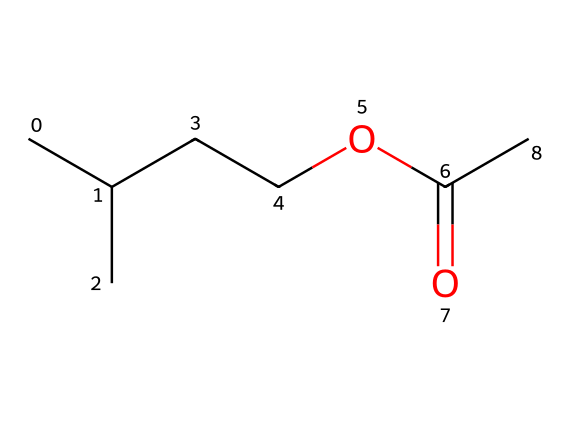What is the name of this chemical? The SMILES representation indicates a molecule made up of five carbon atoms, two from the branched chain and three from the structure connected to the ester functional group. This particular structure corresponds to isopentyl acetate, commonly known for its banana scent.
Answer: isopentyl acetate How many carbon atoms are in isopentyl acetate? By examining the SMILES structure, we see there are five 'C's present, which correspond to the carbon atoms in the molecule. The count includes both the branched and ester sections.
Answer: five What functional group does isopentyl acetate contain? The ester functional group is represented by the segment "OC(=O)", where the carbonyl (C=O) is attached to an oxygen that links to the hydrocarbon part. This identifies it as an ester.
Answer: ester What is the molecular formula for isopentyl acetate? From the SMILES representation, we can derive the number of atoms: 5 carbon, 10 hydrogen, and 2 oxygen atoms, leading to the molecular formula C5H10O2.
Answer: C5H10O2 Why does isopentyl acetate smell like bananas? The molecular structure of isopentyl acetate, with specific branching in the carbon chain, creates a smell profile that closely resembles that of natural banana compounds. The presence of the ester group contributes to fruity aromas that mimic those found in bananas.
Answer: fruity aroma 